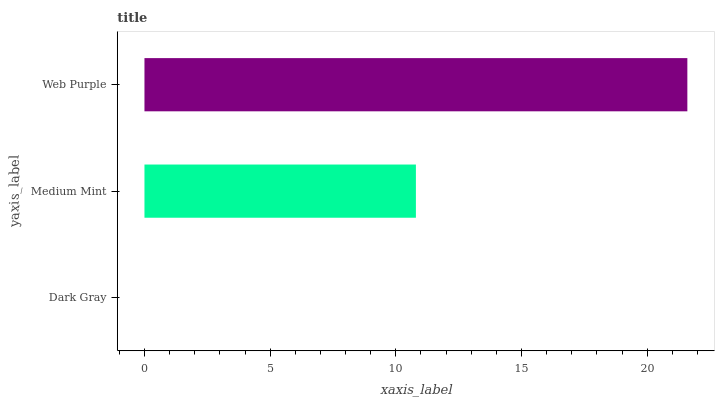Is Dark Gray the minimum?
Answer yes or no. Yes. Is Web Purple the maximum?
Answer yes or no. Yes. Is Medium Mint the minimum?
Answer yes or no. No. Is Medium Mint the maximum?
Answer yes or no. No. Is Medium Mint greater than Dark Gray?
Answer yes or no. Yes. Is Dark Gray less than Medium Mint?
Answer yes or no. Yes. Is Dark Gray greater than Medium Mint?
Answer yes or no. No. Is Medium Mint less than Dark Gray?
Answer yes or no. No. Is Medium Mint the high median?
Answer yes or no. Yes. Is Medium Mint the low median?
Answer yes or no. Yes. Is Web Purple the high median?
Answer yes or no. No. Is Dark Gray the low median?
Answer yes or no. No. 